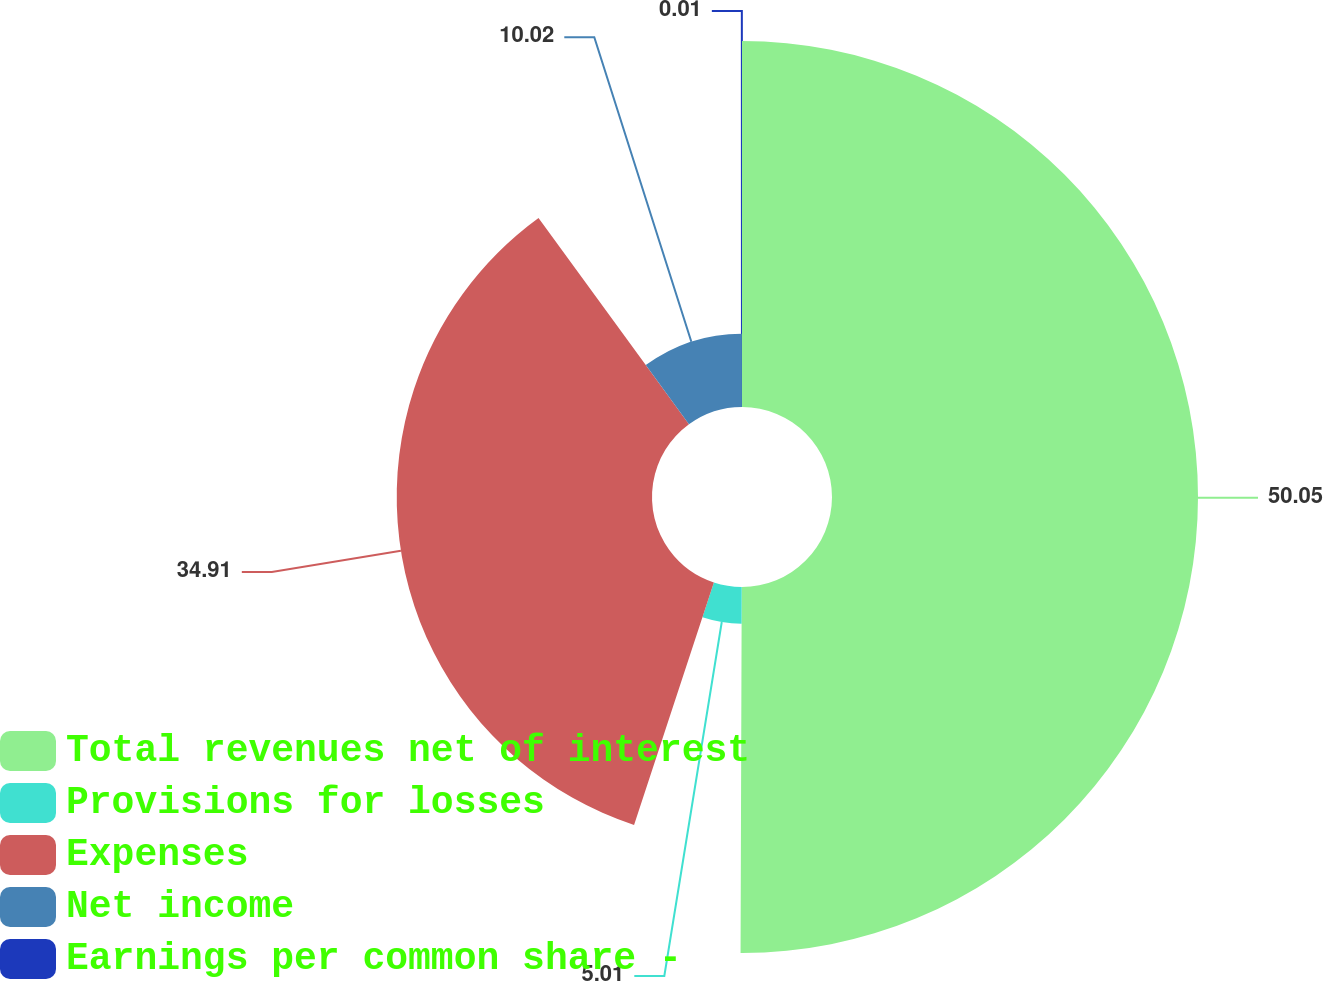Convert chart to OTSL. <chart><loc_0><loc_0><loc_500><loc_500><pie_chart><fcel>Total revenues net of interest<fcel>Provisions for losses<fcel>Expenses<fcel>Net income<fcel>Earnings per common share -<nl><fcel>50.05%<fcel>5.01%<fcel>34.91%<fcel>10.02%<fcel>0.01%<nl></chart> 